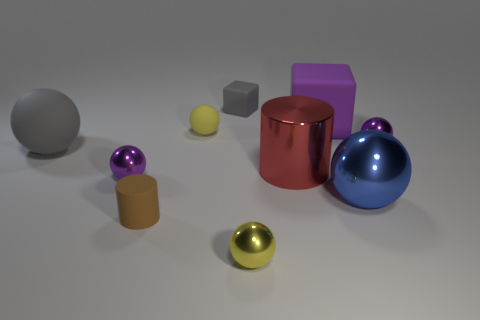Considering the arrangement of the objects, what principles of design seem to have been applied? The arrangement of objects in the image demonstrates principles of design such as balance, contrast, and variety. Balance is achieved through the symmetrical placement of objects across the central axis. Contrast is evident in the differences in colors, sizes, and textures. Variety is introduced with the assortment of shapes and materials, keeping the viewer's interest engaged. 